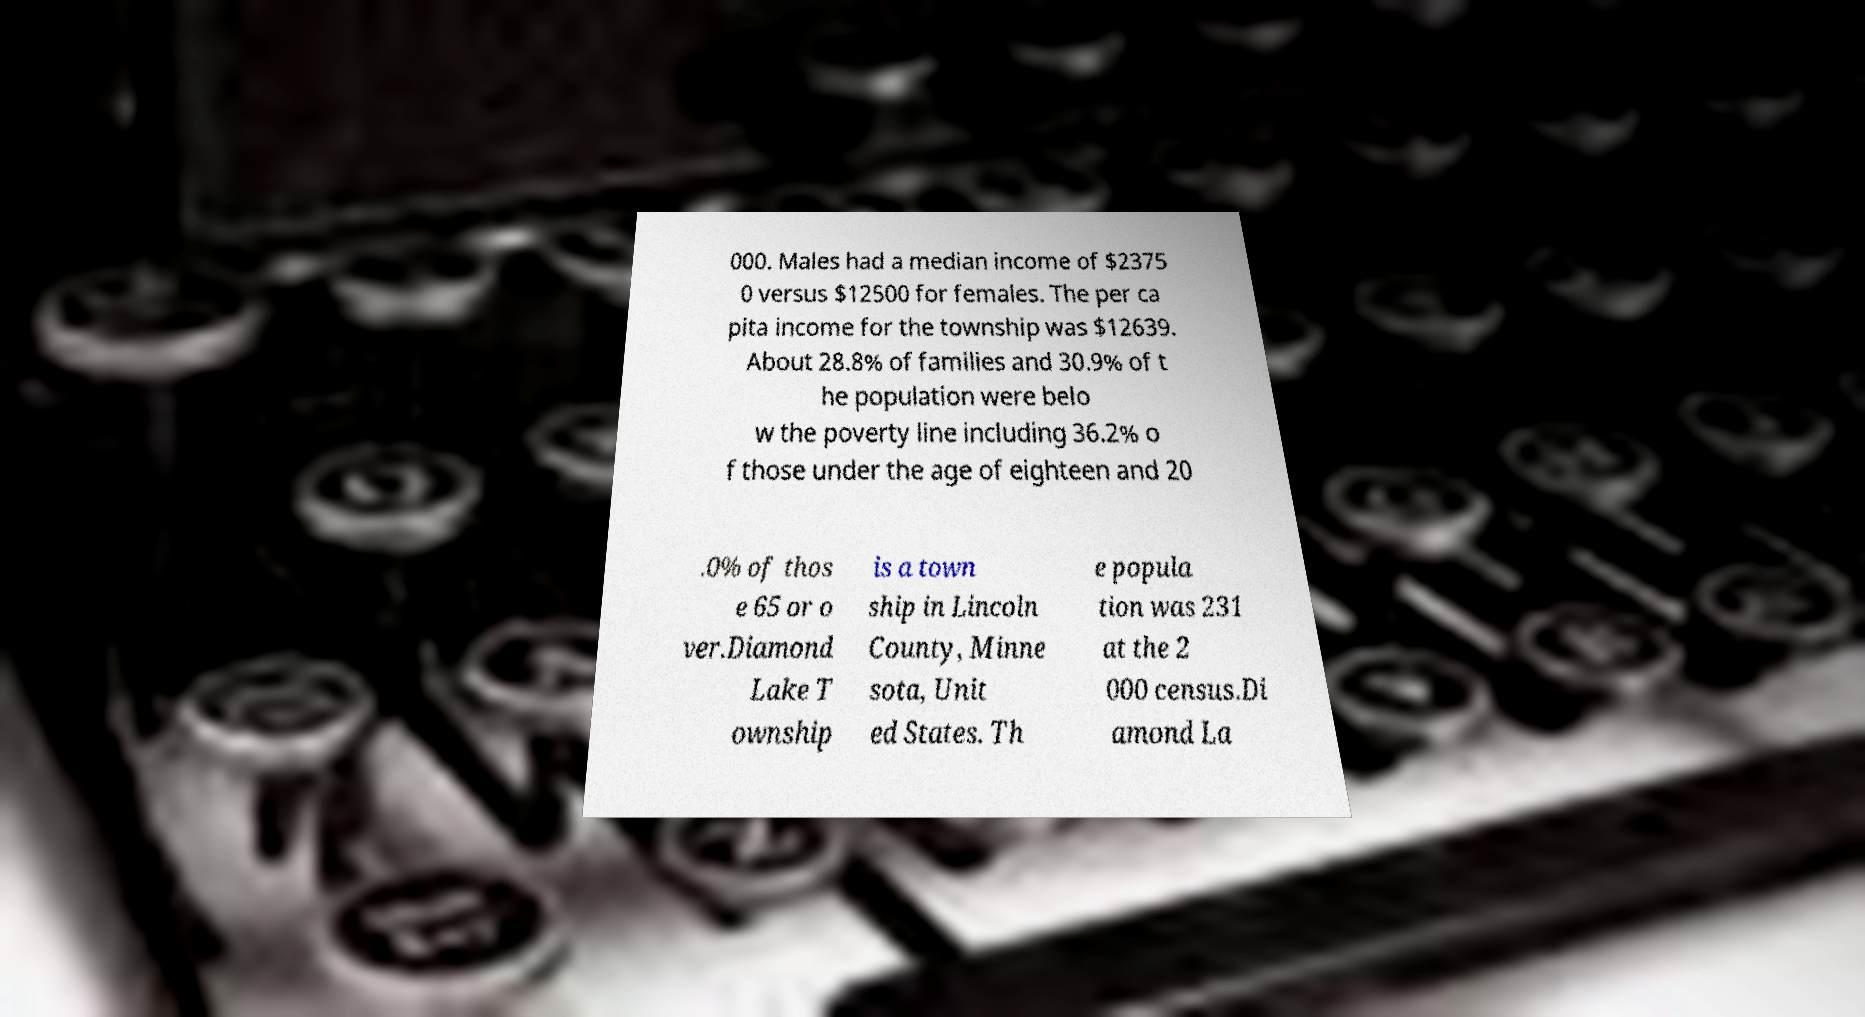Please identify and transcribe the text found in this image. 000. Males had a median income of $2375 0 versus $12500 for females. The per ca pita income for the township was $12639. About 28.8% of families and 30.9% of t he population were belo w the poverty line including 36.2% o f those under the age of eighteen and 20 .0% of thos e 65 or o ver.Diamond Lake T ownship is a town ship in Lincoln County, Minne sota, Unit ed States. Th e popula tion was 231 at the 2 000 census.Di amond La 